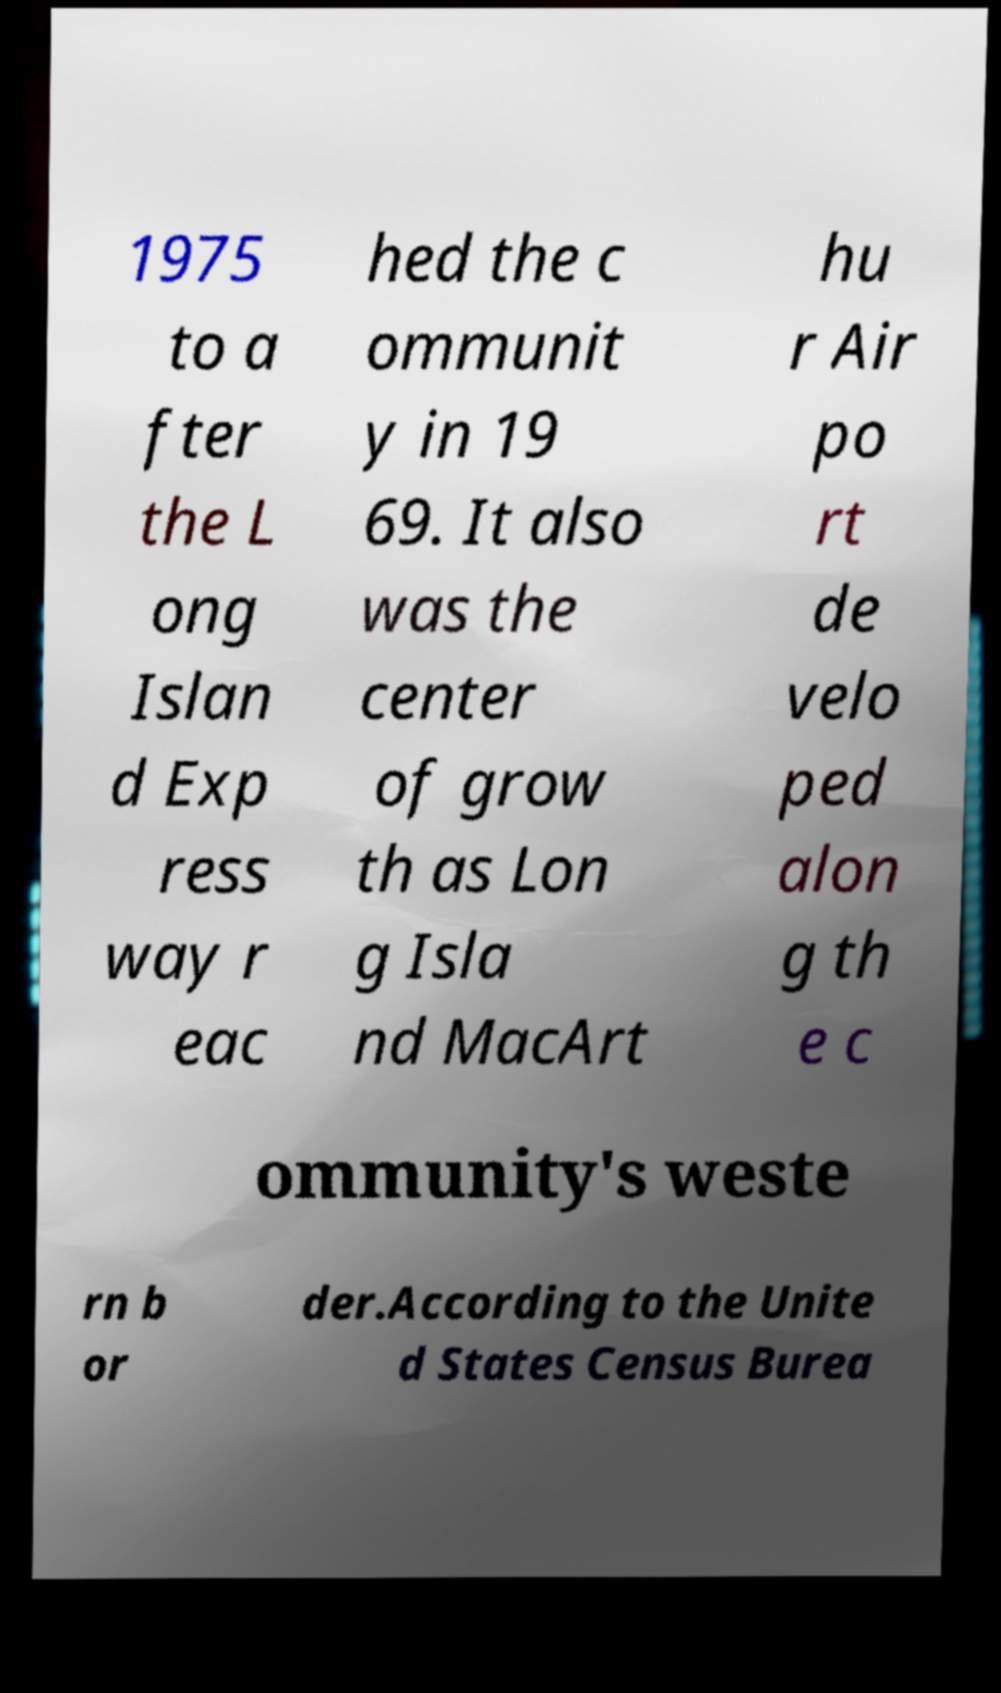There's text embedded in this image that I need extracted. Can you transcribe it verbatim? 1975 to a fter the L ong Islan d Exp ress way r eac hed the c ommunit y in 19 69. It also was the center of grow th as Lon g Isla nd MacArt hu r Air po rt de velo ped alon g th e c ommunity's weste rn b or der.According to the Unite d States Census Burea 